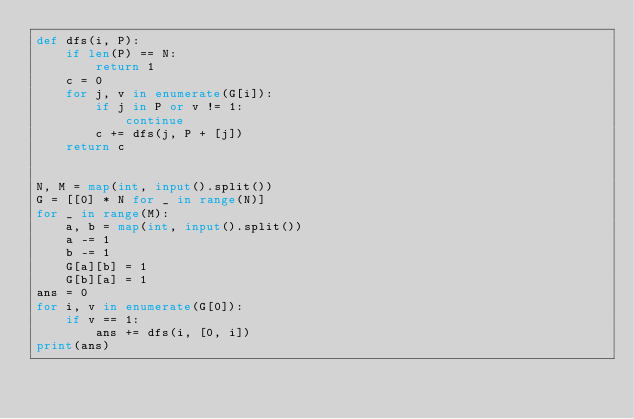Convert code to text. <code><loc_0><loc_0><loc_500><loc_500><_Python_>def dfs(i, P):
    if len(P) == N:
        return 1
    c = 0
    for j, v in enumerate(G[i]):
        if j in P or v != 1:
            continue
        c += dfs(j, P + [j])
    return c


N, M = map(int, input().split())
G = [[0] * N for _ in range(N)]
for _ in range(M):
    a, b = map(int, input().split())
    a -= 1
    b -= 1
    G[a][b] = 1
    G[b][a] = 1
ans = 0
for i, v in enumerate(G[0]):
    if v == 1:
        ans += dfs(i, [0, i])
print(ans)
</code> 